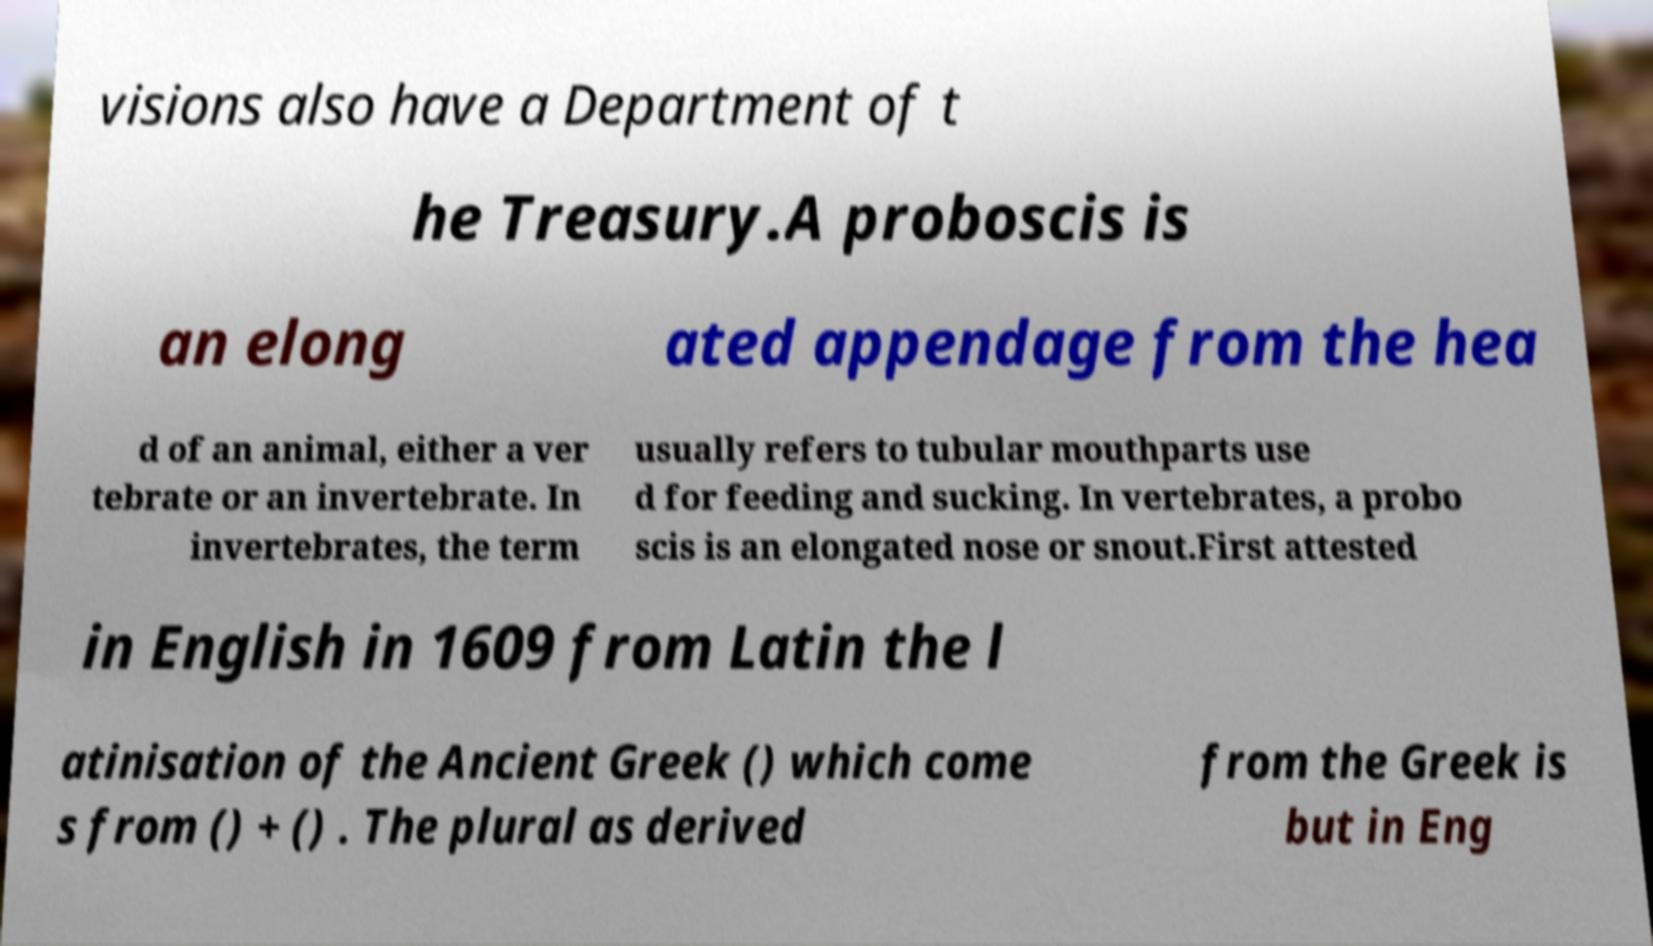Can you accurately transcribe the text from the provided image for me? visions also have a Department of t he Treasury.A proboscis is an elong ated appendage from the hea d of an animal, either a ver tebrate or an invertebrate. In invertebrates, the term usually refers to tubular mouthparts use d for feeding and sucking. In vertebrates, a probo scis is an elongated nose or snout.First attested in English in 1609 from Latin the l atinisation of the Ancient Greek () which come s from () + () . The plural as derived from the Greek is but in Eng 